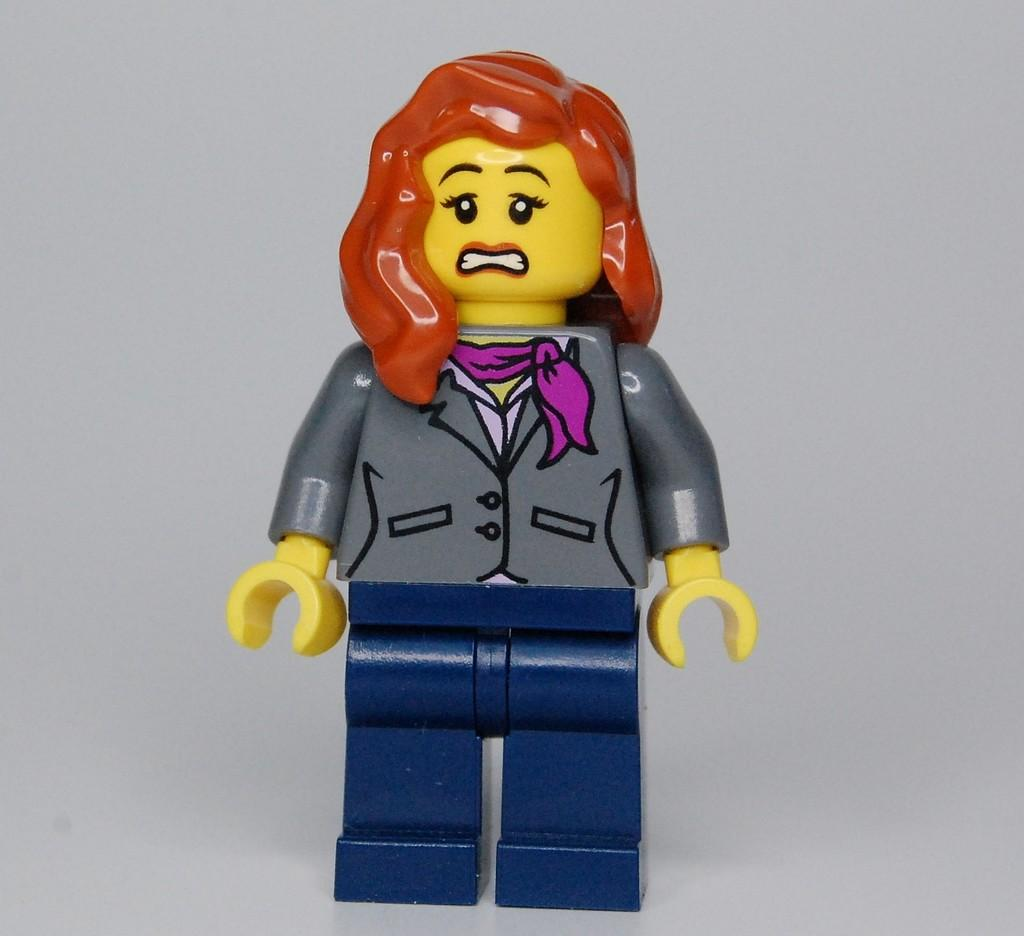What is the main subject in the center of the image? There is a toy in the center of the image. What does the toy represent? The toy represents a person wearing a suit. What is the person in the toy standing on? The person is standing on an object. What type of roof can be seen on the toy's camp in the image? There is no roof or camp present in the image; it features a toy representing a person wearing a suit standing on an object. 